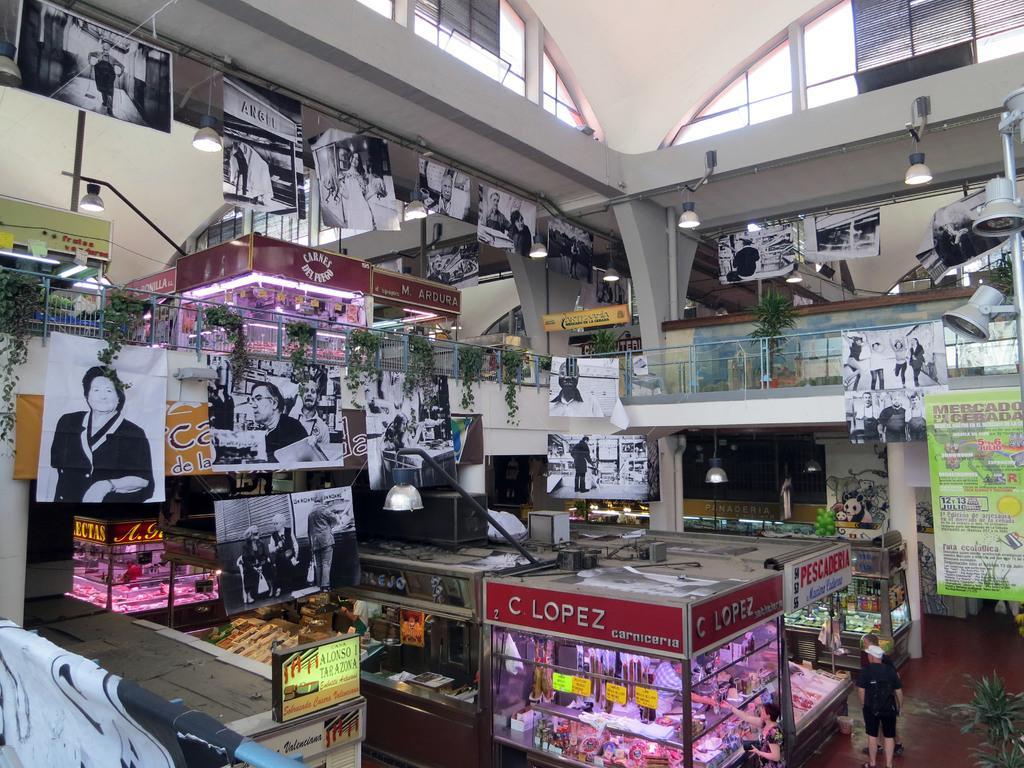How would you summarize this image in a sentence or two? As we can see in the image there is a wall, fence, plants, banners, screen, few people here and there, statues and lights. 